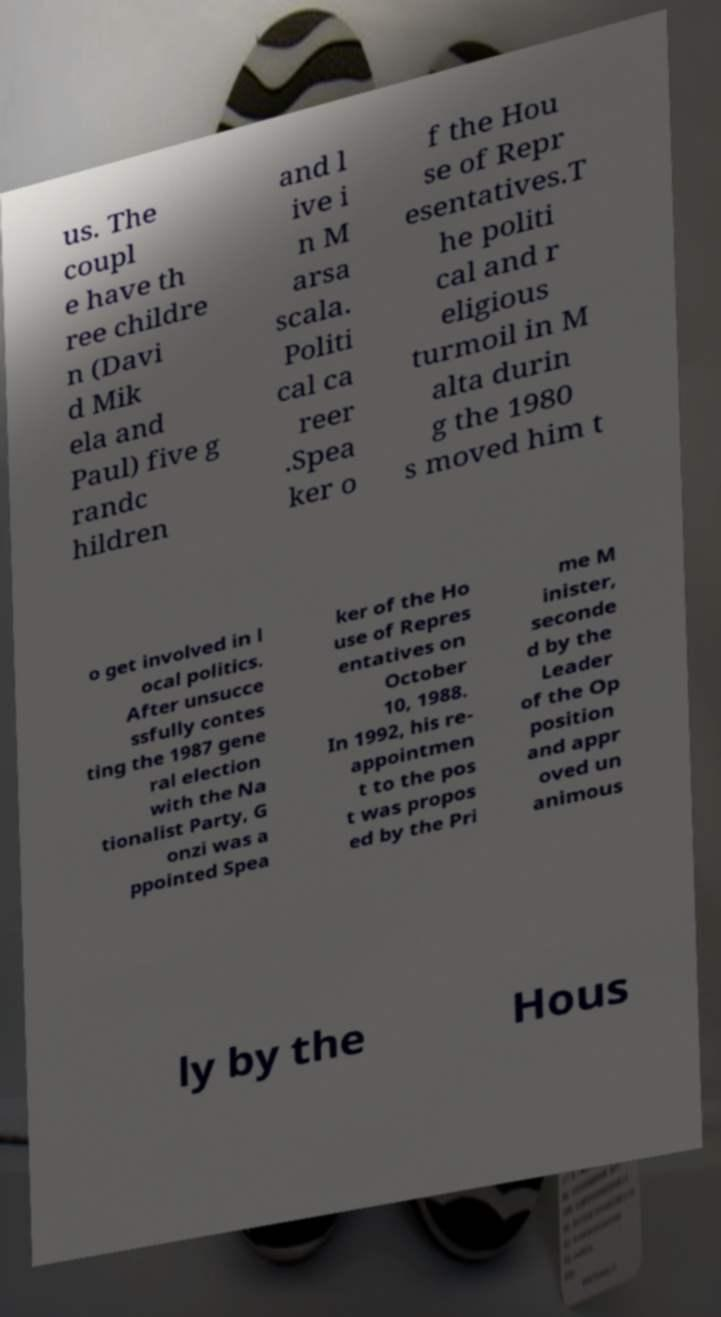There's text embedded in this image that I need extracted. Can you transcribe it verbatim? us. The coupl e have th ree childre n (Davi d Mik ela and Paul) five g randc hildren and l ive i n M arsa scala. Politi cal ca reer .Spea ker o f the Hou se of Repr esentatives.T he politi cal and r eligious turmoil in M alta durin g the 1980 s moved him t o get involved in l ocal politics. After unsucce ssfully contes ting the 1987 gene ral election with the Na tionalist Party, G onzi was a ppointed Spea ker of the Ho use of Repres entatives on October 10, 1988. In 1992, his re- appointmen t to the pos t was propos ed by the Pri me M inister, seconde d by the Leader of the Op position and appr oved un animous ly by the Hous 